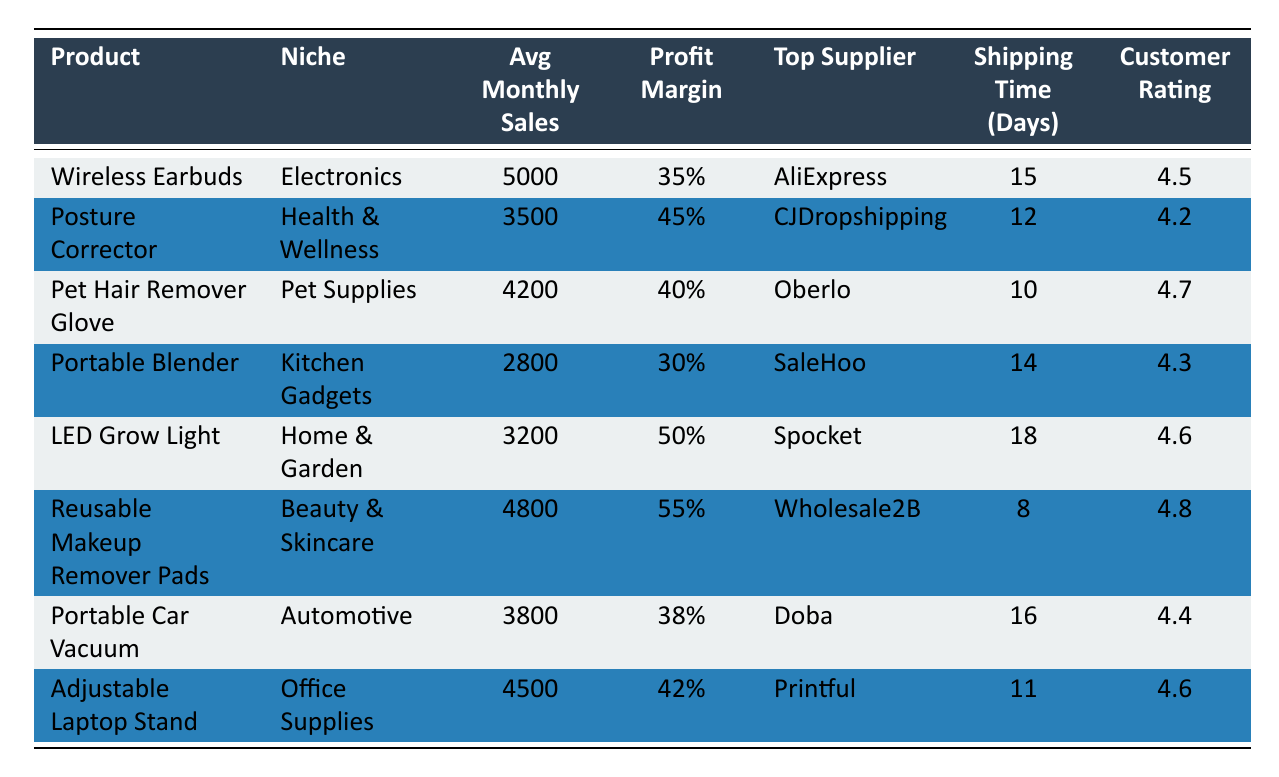What is the product with the highest average monthly sales? By looking at the "Average Monthly Sales" column, the product "Wireless Earbuds" has the highest number at 5000.
Answer: Wireless Earbuds Which product has the highest profit margin in the table? The "Reusable Makeup Remover Pads" have the highest profit margin listed at 55%.
Answer: Reusable Makeup Remover Pads What is the shipping time for the "Pet Hair Remover Glove"? The shipping time for "Pet Hair Remover Glove" is directly found in the table under the shipping time column, which is 10 days.
Answer: 10 days How many products have an average monthly sales figure greater than 4000? The products with average monthly sales greater than 4000 are "Wireless Earbuds" (5000), "Pet Hair Remover Glove" (4200), and "Reusable Makeup Remover Pads" (4800), totaling 3 products.
Answer: 3 Is the average customer rating for "Posture Corrector" higher than 4.5? The customer rating for "Posture Corrector" is 4.2, which is lower than 4.5, so the answer is no.
Answer: No What is the profit margin difference between "LED Grow Light" and "Portable Blender"? The profit margin for "LED Grow Light" is 50% and for "Portable Blender" is 30%. The difference is calculated as 50% - 30% = 20%.
Answer: 20% How long does it take to ship the "Portable Car Vacuum"? In the table, the shipping time for "Portable Car Vacuum" is directly listed as 16 days.
Answer: 16 days What product category has the most products exceeding a customer rating of 4.5? The categories with ratings above 4.5 are "Pet Supplies" (4.7), "Beauty & Skincare" (4.8), and "Office Supplies" (4.6). Thus, "Pet Supplies" and "Beauty & Skincare" both have products exceeding this rating, totaling 3 products across these niches.
Answer: Pet Supplies and Beauty & Skincare Which product has the longest shipping time? The product with the longest shipping time in the table is "LED Grow Light," at 18 days.
Answer: LED Grow Light 